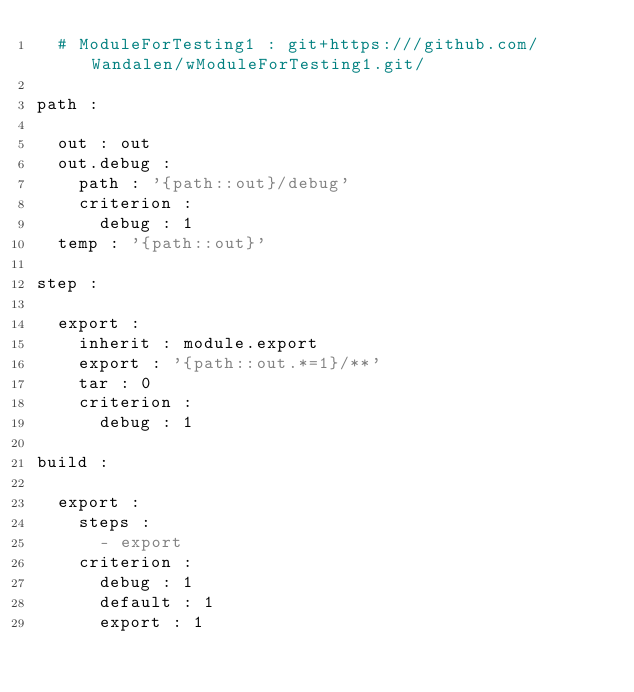Convert code to text. <code><loc_0><loc_0><loc_500><loc_500><_YAML_>  # ModuleForTesting1 : git+https:///github.com/Wandalen/wModuleForTesting1.git/

path :

  out : out
  out.debug :
    path : '{path::out}/debug'
    criterion :
      debug : 1
  temp : '{path::out}'

step :

  export :
    inherit : module.export
    export : '{path::out.*=1}/**'
    tar : 0
    criterion :
      debug : 1

build :

  export :
    steps :
      - export
    criterion :
      debug : 1
      default : 1
      export : 1
</code> 